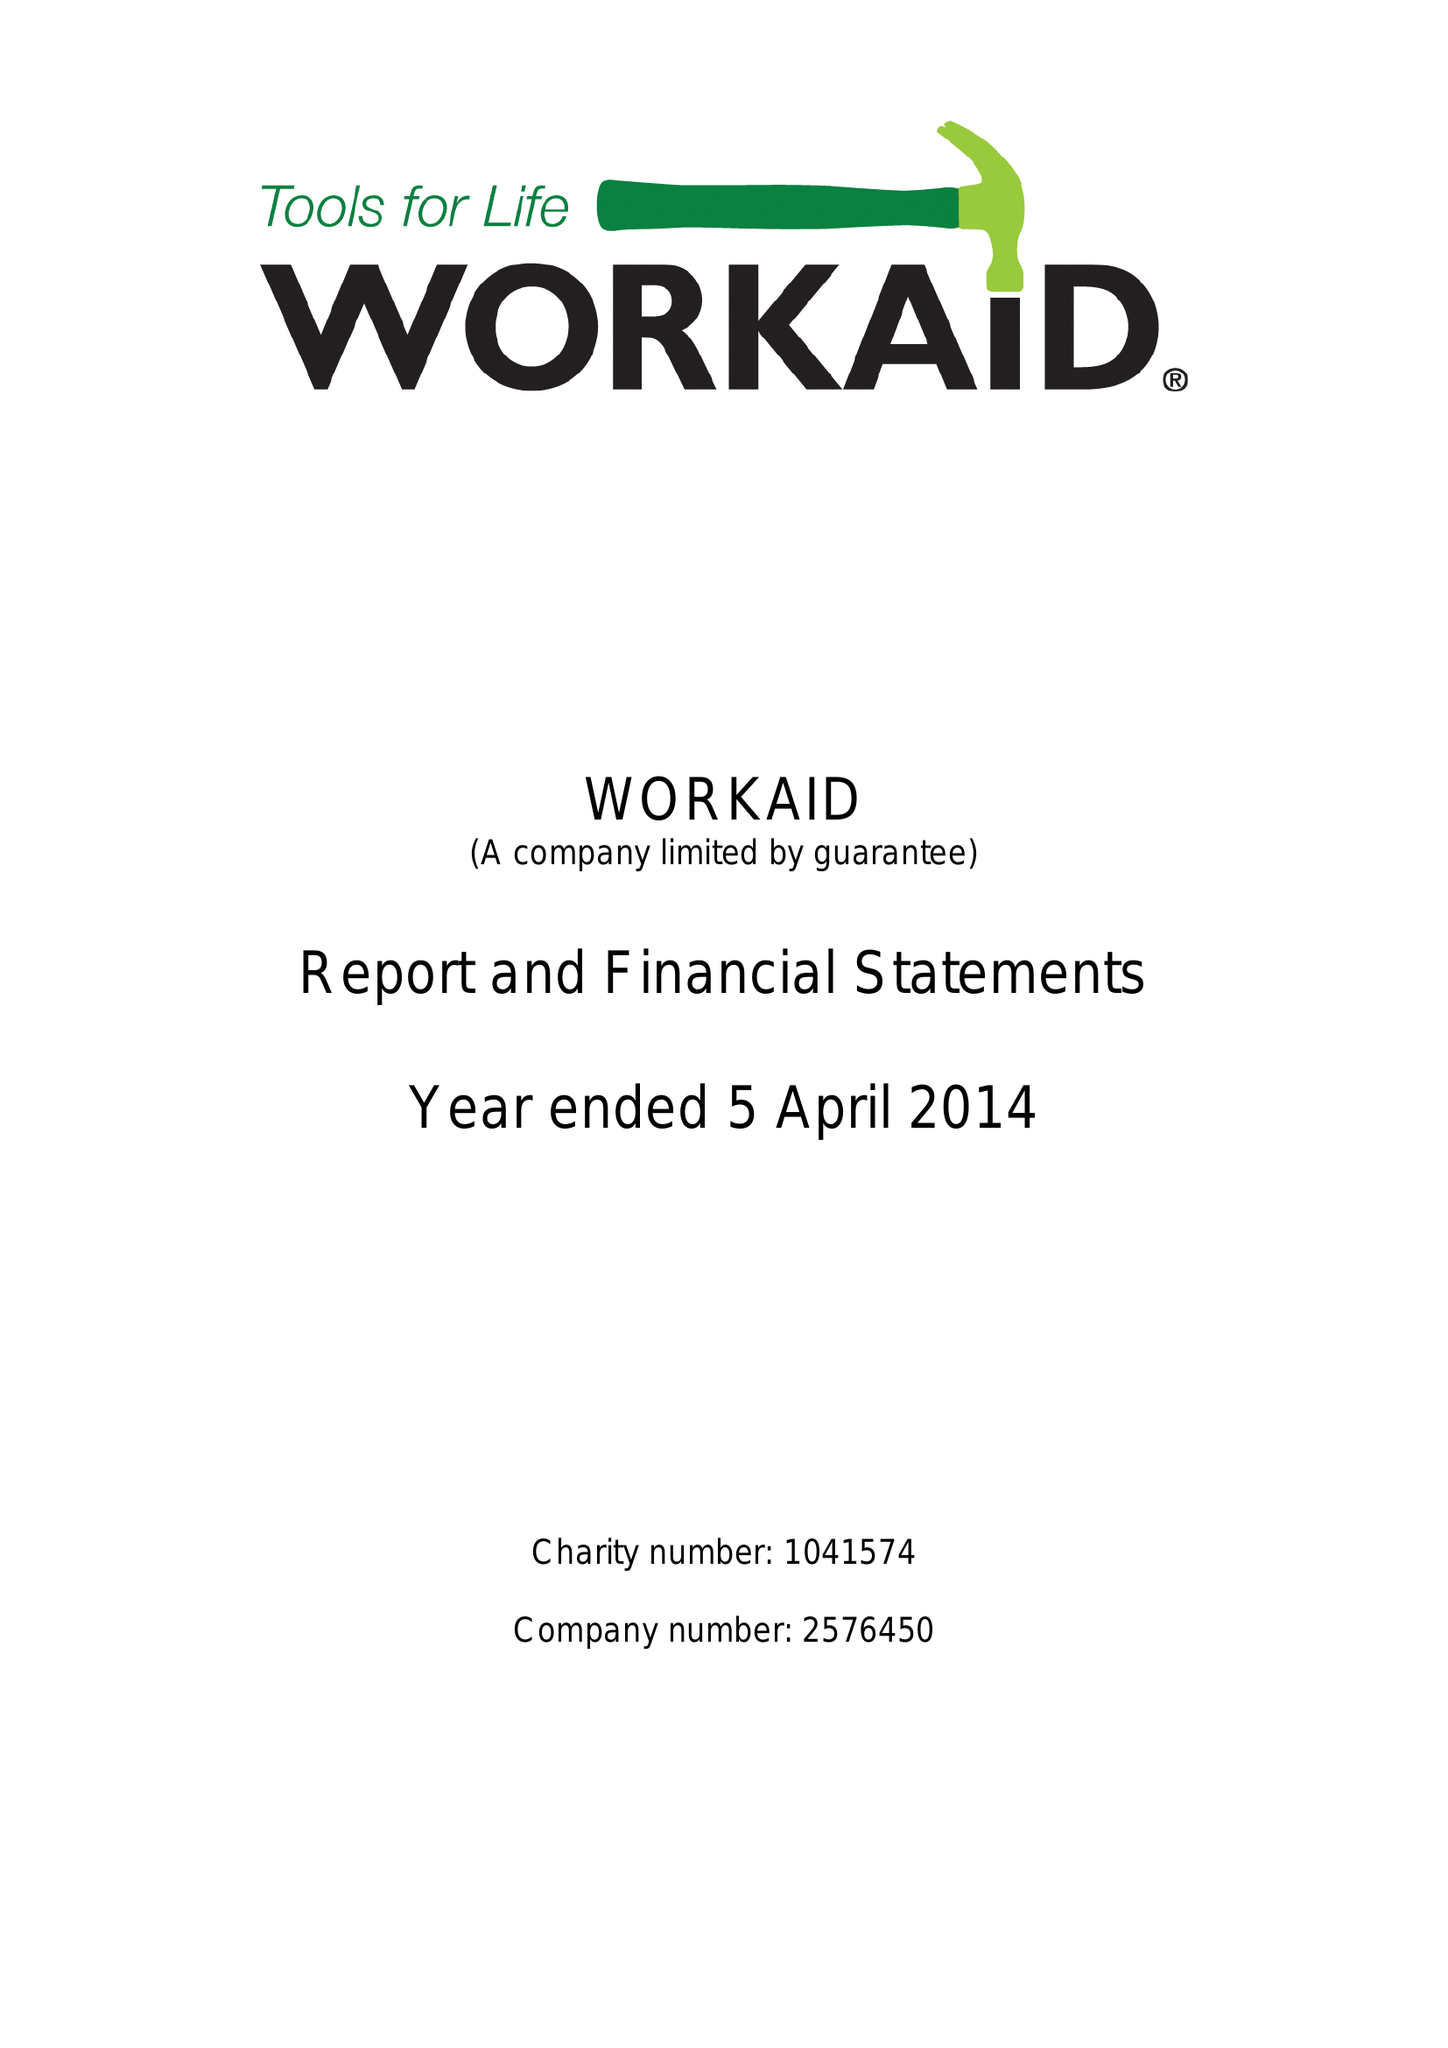What is the value for the address__post_town?
Answer the question using a single word or phrase. CHESHAM 